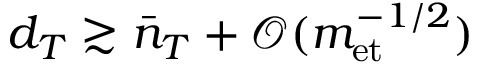<formula> <loc_0><loc_0><loc_500><loc_500>d _ { T } \gtrsim \bar { n } _ { T } + \mathcal { O } ( m _ { e t } ^ { - 1 / 2 } )</formula> 